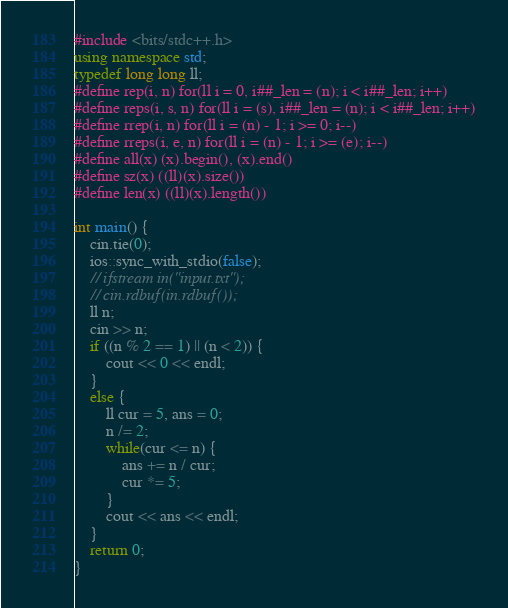Convert code to text. <code><loc_0><loc_0><loc_500><loc_500><_C++_>#include <bits/stdc++.h>
using namespace std;
typedef long long ll;
#define rep(i, n) for(ll i = 0, i##_len = (n); i < i##_len; i++)
#define reps(i, s, n) for(ll i = (s), i##_len = (n); i < i##_len; i++)
#define rrep(i, n) for(ll i = (n) - 1; i >= 0; i--)
#define rreps(i, e, n) for(ll i = (n) - 1; i >= (e); i--)
#define all(x) (x).begin(), (x).end()
#define sz(x) ((ll)(x).size())
#define len(x) ((ll)(x).length())

int main() {
    cin.tie(0);
    ios::sync_with_stdio(false);
    // ifstream in("input.txt");
    // cin.rdbuf(in.rdbuf());
    ll n;
    cin >> n;
    if ((n % 2 == 1) || (n < 2)) {
        cout << 0 << endl;
    }
    else {
        ll cur = 5, ans = 0;
        n /= 2;
        while(cur <= n) {
            ans += n / cur;
            cur *= 5;
        }
        cout << ans << endl;
    }
    return 0;
}
</code> 